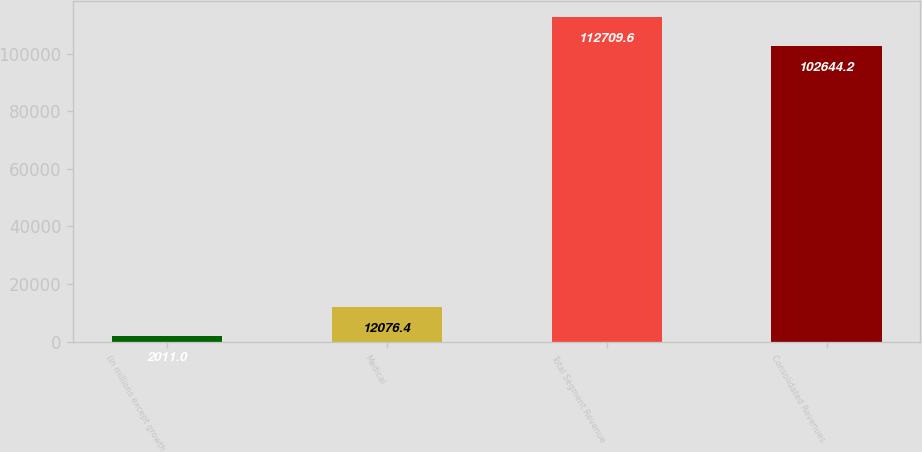<chart> <loc_0><loc_0><loc_500><loc_500><bar_chart><fcel>(in millions except growth<fcel>Medical<fcel>Total Segment Revenue<fcel>Consolidated Revenues<nl><fcel>2011<fcel>12076.4<fcel>112710<fcel>102644<nl></chart> 